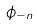<formula> <loc_0><loc_0><loc_500><loc_500>\phi _ { - n }</formula> 